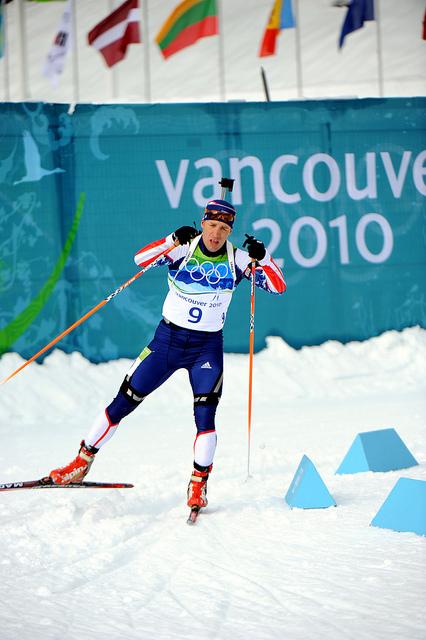What number is the man wearing on his shirt?
Answer briefly. 9. What year was this taken?
Be succinct. 2010. What sport is this?
Answer briefly. Skiing. 